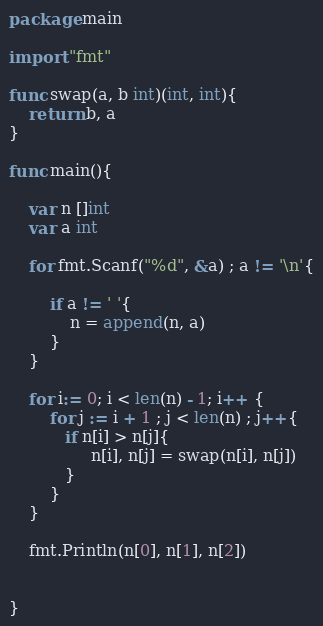Convert code to text. <code><loc_0><loc_0><loc_500><loc_500><_Go_>package main

import "fmt"

func swap(a, b int)(int, int){
    return b, a 
}

func main(){

    var n []int
    var a int

    for fmt.Scanf("%d", &a) ; a != '\n'{

        if a != ' '{ 
            n = append(n, a) 
        }
    }
 
    for i:= 0; i < len(n) - 1; i++ {
        for j := i + 1 ; j < len(n) ; j++{
           if n[i] > n[j]{
                n[i], n[j] = swap(n[i], n[j])
           }
        }
    } 
    
    fmt.Println(n[0], n[1], n[2])


}
</code> 